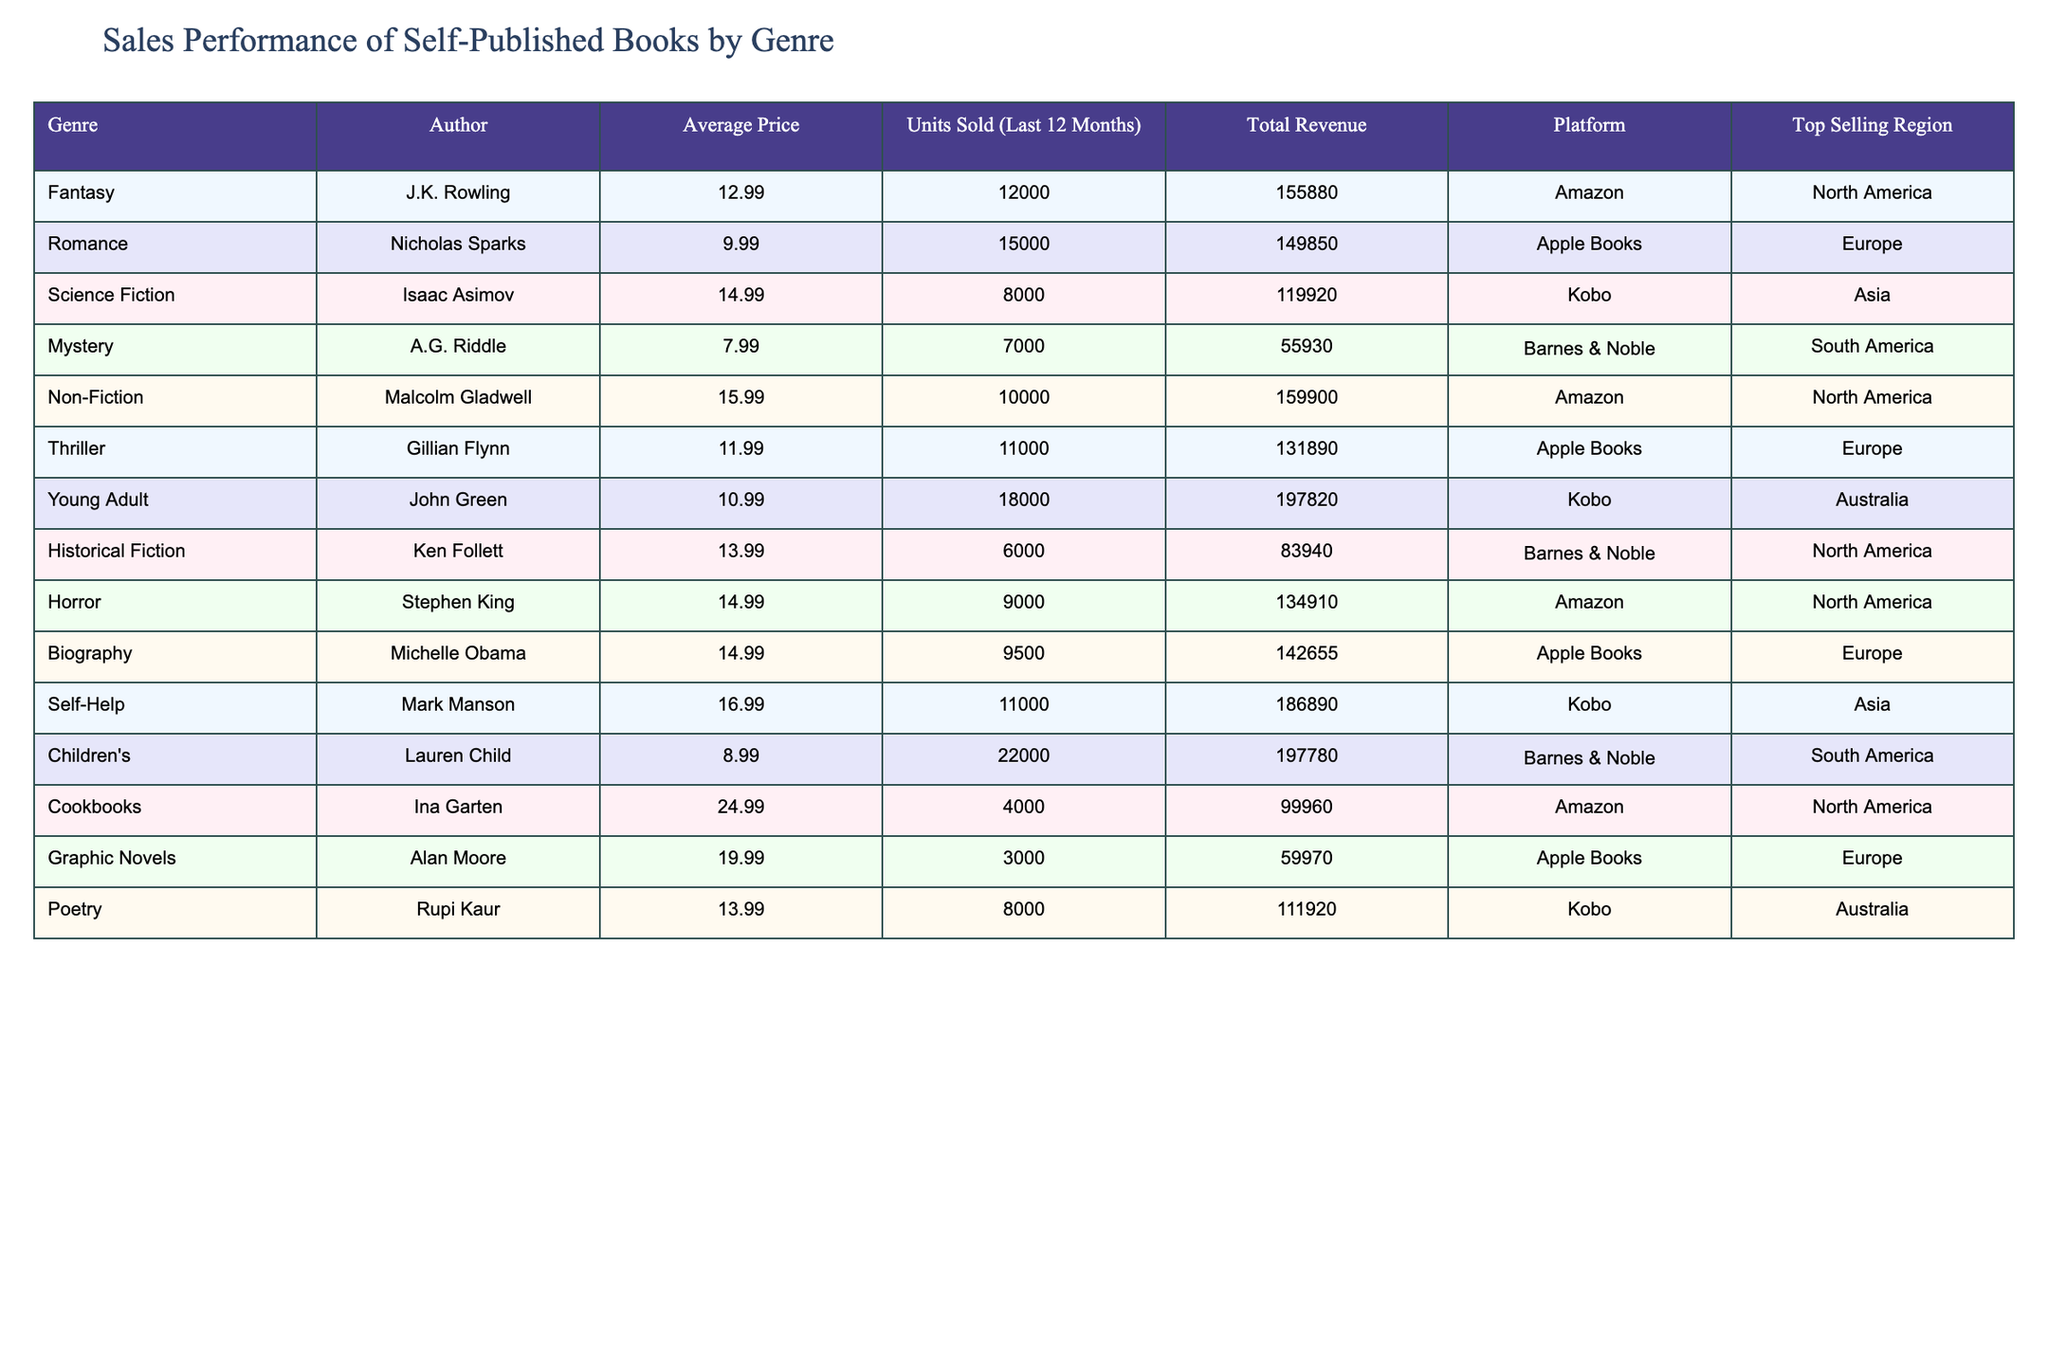What is the average price of the books in the Fantasy genre? From the table, the average price for the Fantasy genre is listed as $12.99.
Answer: $12.99 Which genre sold the most units in the last 12 months? Reviewing the units sold column, the Children's genre sold 22,000 units, which is the highest among all genres.
Answer: Children's What is the total revenue generated by the Self-Help genre? The table shows that the Self-Help genre generated a total revenue of $186,890.
Answer: $186,890 Is the top-selling region for Mystery genre in North America? The table states that the top-selling region for the Mystery genre is South America, therefore, the statement is false.
Answer: No What is the revenue difference between the Romance and Thriller genres? The revenue for Romance is $149,850 and for Thriller is $131,890. The difference is $149,850 - $131,890 = $17,960.
Answer: $17,960 Which platform had the highest revenue from the listed genres? The Amazon platform has multiple entries, and summing the revenues gives $155,880 (Fantasy) + $159,900 (Non-Fiction) + $134,910 (Horror) + $99,960 (Cookbooks) = $550,650. Comparing this to the total revenues of other platforms, Amazon has the highest.
Answer: Amazon What percentage of total units sold does the Young Adult genre represent? The total units sold across all genres is 12000 + 15000 + 8000 + 7000 + 10000 + 11000 + 18000 + 6000 + 9000 + 9500 + 11000 + 22000 + 4000 + 3000 + 8000 = 132,000. The Young Adult genre sold 18,000 units. Calculating the percentage: (18000 / 132000) * 100 = 13.64%.
Answer: 13.64% Which genre has the lowest average price and what is that price? The lowest average price in the table is for the Mystery genre, listed at $7.99.
Answer: $7.99 Are there more books sold through Kobo or Apple Books? The units sold through Kobo are 8,000 (Science Fiction) + 18,000 (Young Adult) + 11,000 (Self-Help) = 37,000. For Apple Books, the units sold are 15,000 (Romance) + 11,000 (Thriller) + 9,500 (Biography) + 3,000 (Graphic Novels) = 38,500. Comparing these, Apple Books has more sold.
Answer: Apple Books What trends can we observe regarding the Top Selling Regions across genres? Analyzing the regions, North America has the most diverse entries (Fantasy, Non-Fiction, Horror, Historical Fiction, Cookbooks), while Europe has Romance, Thriller, and Biography. This suggests North America may have a stronger market presence for self-published authors in various genres.
Answer: North America is more diverse 